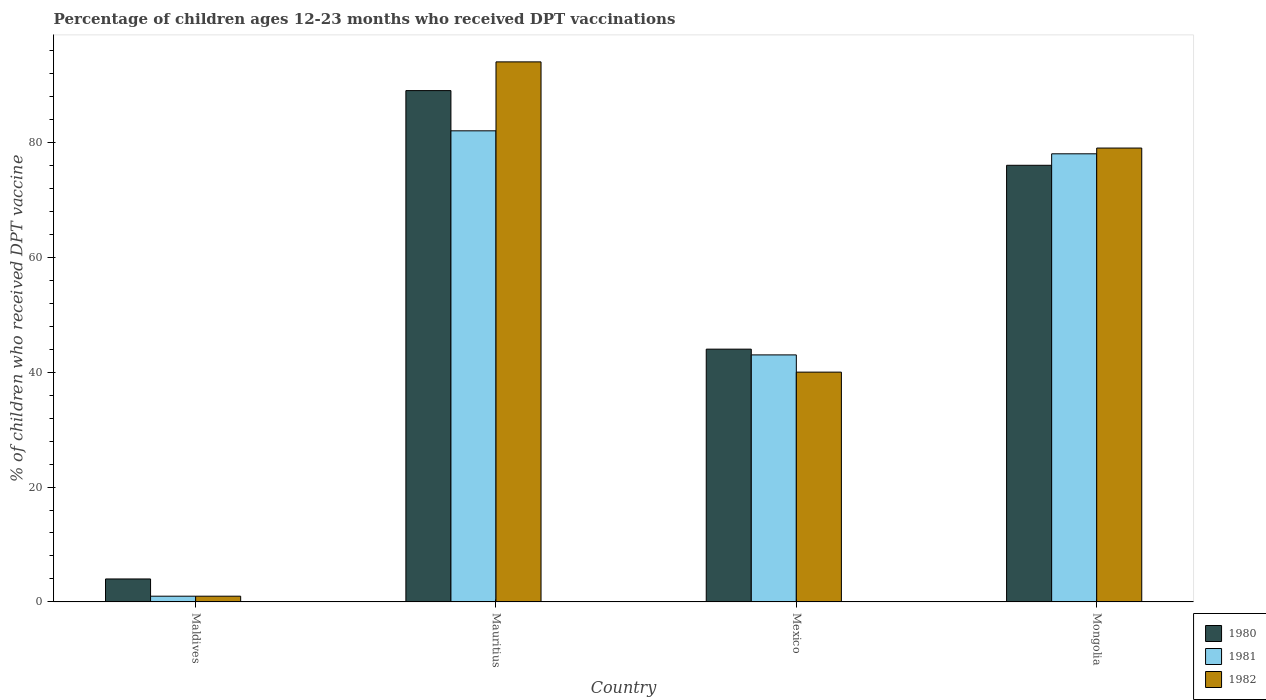How many different coloured bars are there?
Keep it short and to the point. 3. Are the number of bars per tick equal to the number of legend labels?
Keep it short and to the point. Yes. What is the label of the 4th group of bars from the left?
Give a very brief answer. Mongolia. In how many cases, is the number of bars for a given country not equal to the number of legend labels?
Make the answer very short. 0. Across all countries, what is the maximum percentage of children who received DPT vaccination in 1982?
Offer a very short reply. 94. In which country was the percentage of children who received DPT vaccination in 1980 maximum?
Ensure brevity in your answer.  Mauritius. In which country was the percentage of children who received DPT vaccination in 1982 minimum?
Keep it short and to the point. Maldives. What is the total percentage of children who received DPT vaccination in 1981 in the graph?
Provide a succinct answer. 204. What is the difference between the percentage of children who received DPT vaccination in 1981 in Maldives and that in Mongolia?
Provide a succinct answer. -77. What is the average percentage of children who received DPT vaccination in 1980 per country?
Your answer should be very brief. 53.25. What is the difference between the percentage of children who received DPT vaccination of/in 1980 and percentage of children who received DPT vaccination of/in 1981 in Maldives?
Provide a short and direct response. 3. In how many countries, is the percentage of children who received DPT vaccination in 1980 greater than 76 %?
Ensure brevity in your answer.  1. What is the ratio of the percentage of children who received DPT vaccination in 1980 in Mauritius to that in Mongolia?
Keep it short and to the point. 1.17. Is the percentage of children who received DPT vaccination in 1982 in Mauritius less than that in Mongolia?
Make the answer very short. No. What is the difference between the highest and the second highest percentage of children who received DPT vaccination in 1980?
Offer a terse response. 13. What is the difference between the highest and the lowest percentage of children who received DPT vaccination in 1982?
Your answer should be compact. 93. Is the sum of the percentage of children who received DPT vaccination in 1982 in Mauritius and Mexico greater than the maximum percentage of children who received DPT vaccination in 1980 across all countries?
Offer a very short reply. Yes. What does the 3rd bar from the right in Maldives represents?
Give a very brief answer. 1980. How many bars are there?
Provide a short and direct response. 12. Are all the bars in the graph horizontal?
Your answer should be compact. No. How many countries are there in the graph?
Your answer should be compact. 4. What is the difference between two consecutive major ticks on the Y-axis?
Keep it short and to the point. 20. How are the legend labels stacked?
Keep it short and to the point. Vertical. What is the title of the graph?
Offer a very short reply. Percentage of children ages 12-23 months who received DPT vaccinations. Does "2015" appear as one of the legend labels in the graph?
Provide a succinct answer. No. What is the label or title of the Y-axis?
Ensure brevity in your answer.  % of children who received DPT vaccine. What is the % of children who received DPT vaccine in 1980 in Maldives?
Offer a terse response. 4. What is the % of children who received DPT vaccine in 1981 in Maldives?
Your response must be concise. 1. What is the % of children who received DPT vaccine of 1980 in Mauritius?
Offer a very short reply. 89. What is the % of children who received DPT vaccine in 1982 in Mauritius?
Give a very brief answer. 94. What is the % of children who received DPT vaccine of 1980 in Mongolia?
Your answer should be very brief. 76. What is the % of children who received DPT vaccine of 1982 in Mongolia?
Your answer should be compact. 79. Across all countries, what is the maximum % of children who received DPT vaccine in 1980?
Make the answer very short. 89. Across all countries, what is the maximum % of children who received DPT vaccine of 1982?
Ensure brevity in your answer.  94. Across all countries, what is the minimum % of children who received DPT vaccine in 1982?
Your answer should be compact. 1. What is the total % of children who received DPT vaccine of 1980 in the graph?
Provide a succinct answer. 213. What is the total % of children who received DPT vaccine in 1981 in the graph?
Provide a short and direct response. 204. What is the total % of children who received DPT vaccine of 1982 in the graph?
Offer a terse response. 214. What is the difference between the % of children who received DPT vaccine in 1980 in Maldives and that in Mauritius?
Provide a succinct answer. -85. What is the difference between the % of children who received DPT vaccine of 1981 in Maldives and that in Mauritius?
Offer a very short reply. -81. What is the difference between the % of children who received DPT vaccine of 1982 in Maldives and that in Mauritius?
Ensure brevity in your answer.  -93. What is the difference between the % of children who received DPT vaccine in 1980 in Maldives and that in Mexico?
Make the answer very short. -40. What is the difference between the % of children who received DPT vaccine of 1981 in Maldives and that in Mexico?
Give a very brief answer. -42. What is the difference between the % of children who received DPT vaccine in 1982 in Maldives and that in Mexico?
Give a very brief answer. -39. What is the difference between the % of children who received DPT vaccine of 1980 in Maldives and that in Mongolia?
Give a very brief answer. -72. What is the difference between the % of children who received DPT vaccine in 1981 in Maldives and that in Mongolia?
Make the answer very short. -77. What is the difference between the % of children who received DPT vaccine in 1982 in Maldives and that in Mongolia?
Offer a terse response. -78. What is the difference between the % of children who received DPT vaccine of 1980 in Mauritius and that in Mexico?
Make the answer very short. 45. What is the difference between the % of children who received DPT vaccine in 1982 in Mauritius and that in Mexico?
Give a very brief answer. 54. What is the difference between the % of children who received DPT vaccine in 1980 in Mauritius and that in Mongolia?
Provide a succinct answer. 13. What is the difference between the % of children who received DPT vaccine of 1981 in Mauritius and that in Mongolia?
Your response must be concise. 4. What is the difference between the % of children who received DPT vaccine of 1982 in Mauritius and that in Mongolia?
Offer a terse response. 15. What is the difference between the % of children who received DPT vaccine of 1980 in Mexico and that in Mongolia?
Your answer should be very brief. -32. What is the difference between the % of children who received DPT vaccine in 1981 in Mexico and that in Mongolia?
Your response must be concise. -35. What is the difference between the % of children who received DPT vaccine of 1982 in Mexico and that in Mongolia?
Offer a terse response. -39. What is the difference between the % of children who received DPT vaccine in 1980 in Maldives and the % of children who received DPT vaccine in 1981 in Mauritius?
Offer a terse response. -78. What is the difference between the % of children who received DPT vaccine of 1980 in Maldives and the % of children who received DPT vaccine of 1982 in Mauritius?
Your answer should be compact. -90. What is the difference between the % of children who received DPT vaccine of 1981 in Maldives and the % of children who received DPT vaccine of 1982 in Mauritius?
Make the answer very short. -93. What is the difference between the % of children who received DPT vaccine in 1980 in Maldives and the % of children who received DPT vaccine in 1981 in Mexico?
Offer a very short reply. -39. What is the difference between the % of children who received DPT vaccine of 1980 in Maldives and the % of children who received DPT vaccine of 1982 in Mexico?
Make the answer very short. -36. What is the difference between the % of children who received DPT vaccine in 1981 in Maldives and the % of children who received DPT vaccine in 1982 in Mexico?
Offer a terse response. -39. What is the difference between the % of children who received DPT vaccine in 1980 in Maldives and the % of children who received DPT vaccine in 1981 in Mongolia?
Give a very brief answer. -74. What is the difference between the % of children who received DPT vaccine in 1980 in Maldives and the % of children who received DPT vaccine in 1982 in Mongolia?
Your response must be concise. -75. What is the difference between the % of children who received DPT vaccine in 1981 in Maldives and the % of children who received DPT vaccine in 1982 in Mongolia?
Offer a very short reply. -78. What is the difference between the % of children who received DPT vaccine of 1981 in Mauritius and the % of children who received DPT vaccine of 1982 in Mexico?
Provide a succinct answer. 42. What is the difference between the % of children who received DPT vaccine of 1980 in Mauritius and the % of children who received DPT vaccine of 1981 in Mongolia?
Provide a succinct answer. 11. What is the difference between the % of children who received DPT vaccine in 1980 in Mauritius and the % of children who received DPT vaccine in 1982 in Mongolia?
Give a very brief answer. 10. What is the difference between the % of children who received DPT vaccine of 1980 in Mexico and the % of children who received DPT vaccine of 1981 in Mongolia?
Make the answer very short. -34. What is the difference between the % of children who received DPT vaccine in 1980 in Mexico and the % of children who received DPT vaccine in 1982 in Mongolia?
Ensure brevity in your answer.  -35. What is the difference between the % of children who received DPT vaccine of 1981 in Mexico and the % of children who received DPT vaccine of 1982 in Mongolia?
Your response must be concise. -36. What is the average % of children who received DPT vaccine in 1980 per country?
Provide a short and direct response. 53.25. What is the average % of children who received DPT vaccine of 1982 per country?
Your response must be concise. 53.5. What is the difference between the % of children who received DPT vaccine in 1980 and % of children who received DPT vaccine in 1982 in Maldives?
Keep it short and to the point. 3. What is the difference between the % of children who received DPT vaccine in 1981 and % of children who received DPT vaccine in 1982 in Mauritius?
Your response must be concise. -12. What is the ratio of the % of children who received DPT vaccine of 1980 in Maldives to that in Mauritius?
Your answer should be compact. 0.04. What is the ratio of the % of children who received DPT vaccine in 1981 in Maldives to that in Mauritius?
Make the answer very short. 0.01. What is the ratio of the % of children who received DPT vaccine in 1982 in Maldives to that in Mauritius?
Offer a very short reply. 0.01. What is the ratio of the % of children who received DPT vaccine in 1980 in Maldives to that in Mexico?
Give a very brief answer. 0.09. What is the ratio of the % of children who received DPT vaccine of 1981 in Maldives to that in Mexico?
Provide a succinct answer. 0.02. What is the ratio of the % of children who received DPT vaccine of 1982 in Maldives to that in Mexico?
Ensure brevity in your answer.  0.03. What is the ratio of the % of children who received DPT vaccine in 1980 in Maldives to that in Mongolia?
Ensure brevity in your answer.  0.05. What is the ratio of the % of children who received DPT vaccine in 1981 in Maldives to that in Mongolia?
Ensure brevity in your answer.  0.01. What is the ratio of the % of children who received DPT vaccine in 1982 in Maldives to that in Mongolia?
Your response must be concise. 0.01. What is the ratio of the % of children who received DPT vaccine in 1980 in Mauritius to that in Mexico?
Provide a short and direct response. 2.02. What is the ratio of the % of children who received DPT vaccine in 1981 in Mauritius to that in Mexico?
Your response must be concise. 1.91. What is the ratio of the % of children who received DPT vaccine of 1982 in Mauritius to that in Mexico?
Keep it short and to the point. 2.35. What is the ratio of the % of children who received DPT vaccine in 1980 in Mauritius to that in Mongolia?
Your answer should be very brief. 1.17. What is the ratio of the % of children who received DPT vaccine of 1981 in Mauritius to that in Mongolia?
Provide a succinct answer. 1.05. What is the ratio of the % of children who received DPT vaccine of 1982 in Mauritius to that in Mongolia?
Your response must be concise. 1.19. What is the ratio of the % of children who received DPT vaccine of 1980 in Mexico to that in Mongolia?
Offer a very short reply. 0.58. What is the ratio of the % of children who received DPT vaccine in 1981 in Mexico to that in Mongolia?
Your answer should be very brief. 0.55. What is the ratio of the % of children who received DPT vaccine of 1982 in Mexico to that in Mongolia?
Your response must be concise. 0.51. What is the difference between the highest and the second highest % of children who received DPT vaccine in 1980?
Make the answer very short. 13. What is the difference between the highest and the lowest % of children who received DPT vaccine of 1982?
Offer a terse response. 93. 